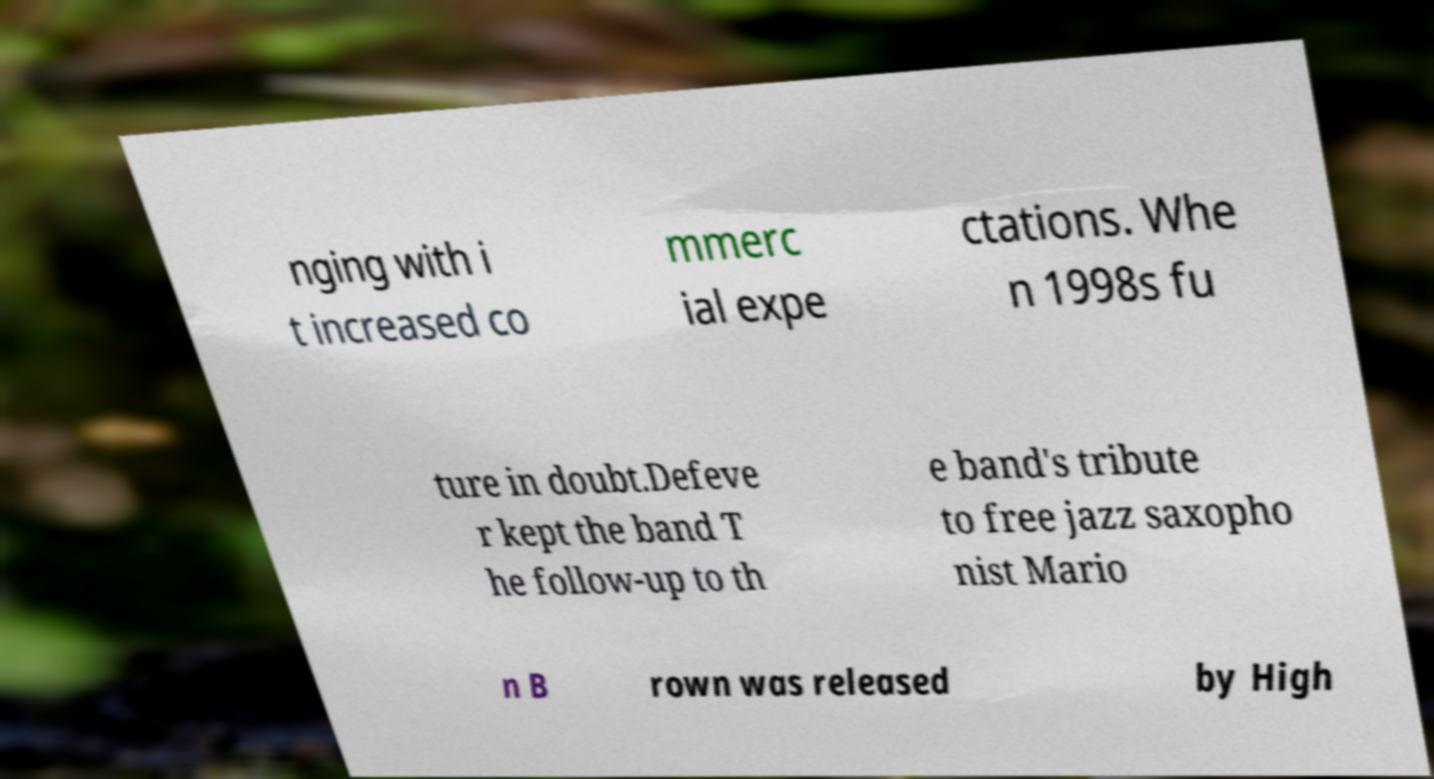Could you extract and type out the text from this image? nging with i t increased co mmerc ial expe ctations. Whe n 1998s fu ture in doubt.Defeve r kept the band T he follow-up to th e band's tribute to free jazz saxopho nist Mario n B rown was released by High 